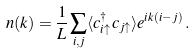<formula> <loc_0><loc_0><loc_500><loc_500>n ( k ) = \frac { 1 } { L } \sum _ { i , j } \langle c _ { i \uparrow } ^ { \dagger } c _ { j \uparrow } \rangle e ^ { i k ( i - j ) } \, .</formula> 